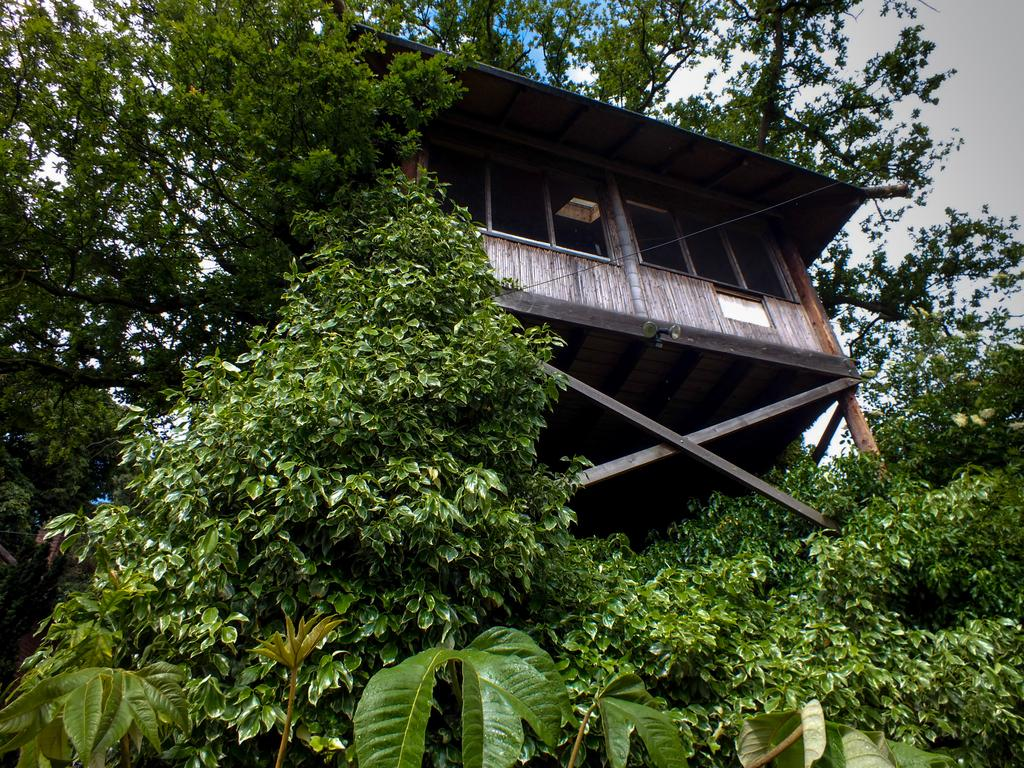What type of house is in the image? There is a wooden house in the image. How are the trees related to the wooden house in the image? The wooden house is covered with trees. What part of the natural environment is visible in the image? Sky is visible in the image. What can be seen in the sky? Clouds are present in the sky. What type of vest is hanging on the wooden house in the image? There is no vest present in the image; it features a wooden house covered with trees and a sky with clouds. 